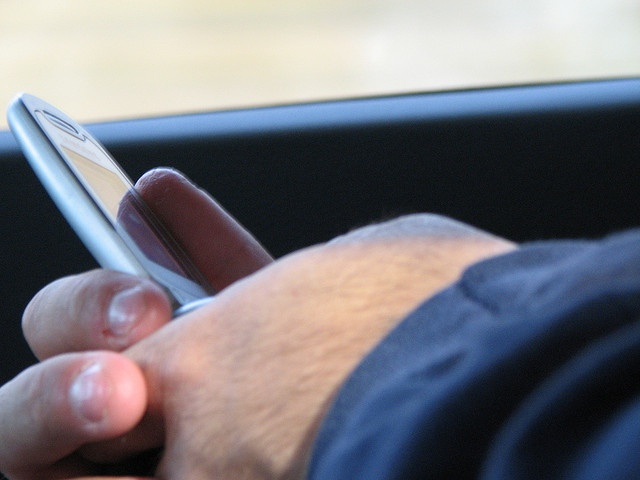Describe the objects in this image and their specific colors. I can see people in beige, black, tan, gray, and darkgray tones and cell phone in beige, lightgray, lightblue, darkgray, and purple tones in this image. 